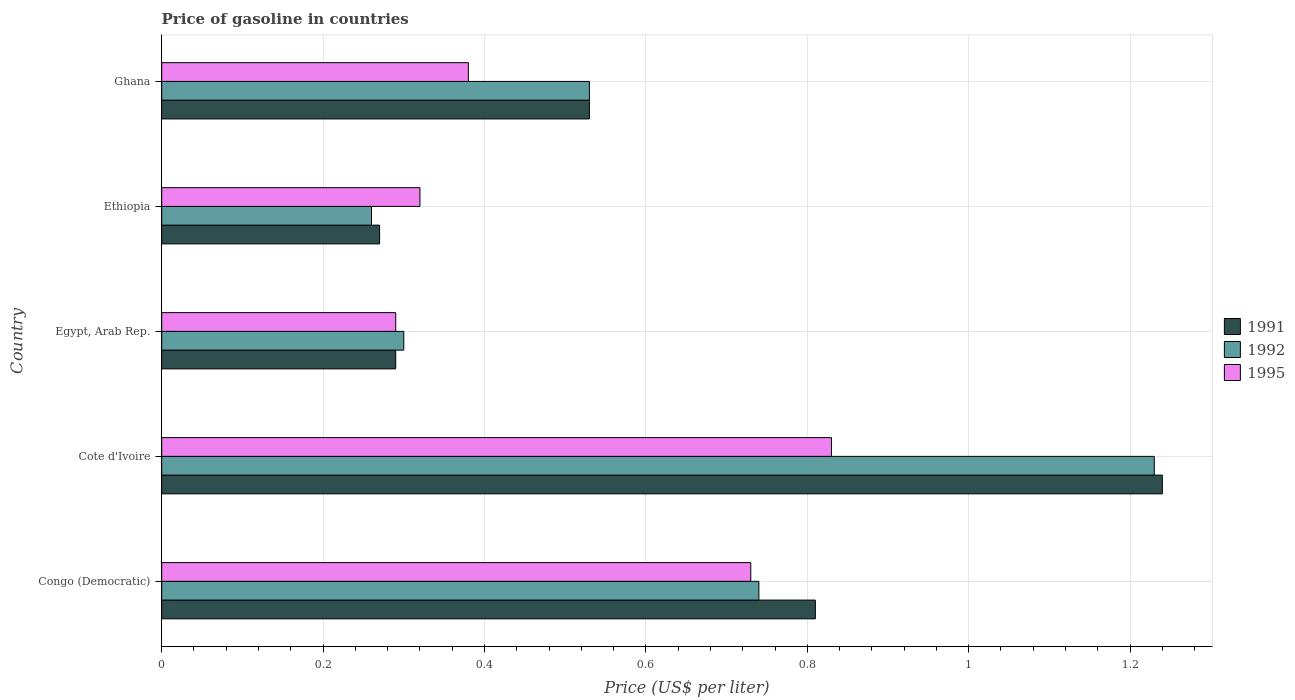How many different coloured bars are there?
Your answer should be compact. 3. How many groups of bars are there?
Your answer should be compact. 5. Are the number of bars per tick equal to the number of legend labels?
Your answer should be very brief. Yes. How many bars are there on the 3rd tick from the top?
Your answer should be very brief. 3. How many bars are there on the 3rd tick from the bottom?
Your response must be concise. 3. What is the label of the 4th group of bars from the top?
Your answer should be compact. Cote d'Ivoire. What is the price of gasoline in 1992 in Cote d'Ivoire?
Give a very brief answer. 1.23. Across all countries, what is the maximum price of gasoline in 1991?
Ensure brevity in your answer.  1.24. Across all countries, what is the minimum price of gasoline in 1992?
Ensure brevity in your answer.  0.26. In which country was the price of gasoline in 1995 maximum?
Your answer should be very brief. Cote d'Ivoire. In which country was the price of gasoline in 1992 minimum?
Offer a terse response. Ethiopia. What is the total price of gasoline in 1992 in the graph?
Your answer should be compact. 3.06. What is the difference between the price of gasoline in 1992 in Egypt, Arab Rep. and that in Ethiopia?
Make the answer very short. 0.04. What is the difference between the price of gasoline in 1995 in Ghana and the price of gasoline in 1992 in Cote d'Ivoire?
Your answer should be compact. -0.85. What is the average price of gasoline in 1992 per country?
Provide a succinct answer. 0.61. What is the difference between the price of gasoline in 1995 and price of gasoline in 1991 in Ghana?
Offer a very short reply. -0.15. In how many countries, is the price of gasoline in 1991 greater than 0.7200000000000001 US$?
Your response must be concise. 2. What is the ratio of the price of gasoline in 1991 in Congo (Democratic) to that in Cote d'Ivoire?
Provide a short and direct response. 0.65. Is the difference between the price of gasoline in 1995 in Congo (Democratic) and Ethiopia greater than the difference between the price of gasoline in 1991 in Congo (Democratic) and Ethiopia?
Give a very brief answer. No. What is the difference between the highest and the second highest price of gasoline in 1995?
Give a very brief answer. 0.1. What is the difference between the highest and the lowest price of gasoline in 1995?
Your answer should be very brief. 0.54. What does the 3rd bar from the top in Ghana represents?
Offer a very short reply. 1991. What does the 2nd bar from the bottom in Congo (Democratic) represents?
Your answer should be very brief. 1992. How many bars are there?
Provide a short and direct response. 15. What is the difference between two consecutive major ticks on the X-axis?
Your response must be concise. 0.2. Are the values on the major ticks of X-axis written in scientific E-notation?
Offer a terse response. No. Does the graph contain any zero values?
Ensure brevity in your answer.  No. How many legend labels are there?
Provide a succinct answer. 3. What is the title of the graph?
Give a very brief answer. Price of gasoline in countries. What is the label or title of the X-axis?
Make the answer very short. Price (US$ per liter). What is the Price (US$ per liter) in 1991 in Congo (Democratic)?
Provide a short and direct response. 0.81. What is the Price (US$ per liter) of 1992 in Congo (Democratic)?
Give a very brief answer. 0.74. What is the Price (US$ per liter) in 1995 in Congo (Democratic)?
Provide a succinct answer. 0.73. What is the Price (US$ per liter) in 1991 in Cote d'Ivoire?
Your response must be concise. 1.24. What is the Price (US$ per liter) of 1992 in Cote d'Ivoire?
Provide a succinct answer. 1.23. What is the Price (US$ per liter) in 1995 in Cote d'Ivoire?
Make the answer very short. 0.83. What is the Price (US$ per liter) in 1991 in Egypt, Arab Rep.?
Give a very brief answer. 0.29. What is the Price (US$ per liter) of 1995 in Egypt, Arab Rep.?
Your answer should be very brief. 0.29. What is the Price (US$ per liter) of 1991 in Ethiopia?
Your answer should be very brief. 0.27. What is the Price (US$ per liter) of 1992 in Ethiopia?
Your answer should be very brief. 0.26. What is the Price (US$ per liter) in 1995 in Ethiopia?
Provide a short and direct response. 0.32. What is the Price (US$ per liter) in 1991 in Ghana?
Offer a very short reply. 0.53. What is the Price (US$ per liter) of 1992 in Ghana?
Keep it short and to the point. 0.53. What is the Price (US$ per liter) of 1995 in Ghana?
Give a very brief answer. 0.38. Across all countries, what is the maximum Price (US$ per liter) in 1991?
Provide a short and direct response. 1.24. Across all countries, what is the maximum Price (US$ per liter) in 1992?
Provide a short and direct response. 1.23. Across all countries, what is the maximum Price (US$ per liter) in 1995?
Give a very brief answer. 0.83. Across all countries, what is the minimum Price (US$ per liter) in 1991?
Your response must be concise. 0.27. Across all countries, what is the minimum Price (US$ per liter) of 1992?
Your answer should be very brief. 0.26. Across all countries, what is the minimum Price (US$ per liter) in 1995?
Offer a terse response. 0.29. What is the total Price (US$ per liter) in 1991 in the graph?
Provide a short and direct response. 3.14. What is the total Price (US$ per liter) of 1992 in the graph?
Your answer should be very brief. 3.06. What is the total Price (US$ per liter) of 1995 in the graph?
Provide a succinct answer. 2.55. What is the difference between the Price (US$ per liter) in 1991 in Congo (Democratic) and that in Cote d'Ivoire?
Your answer should be compact. -0.43. What is the difference between the Price (US$ per liter) of 1992 in Congo (Democratic) and that in Cote d'Ivoire?
Provide a succinct answer. -0.49. What is the difference between the Price (US$ per liter) of 1995 in Congo (Democratic) and that in Cote d'Ivoire?
Provide a succinct answer. -0.1. What is the difference between the Price (US$ per liter) of 1991 in Congo (Democratic) and that in Egypt, Arab Rep.?
Offer a very short reply. 0.52. What is the difference between the Price (US$ per liter) of 1992 in Congo (Democratic) and that in Egypt, Arab Rep.?
Offer a very short reply. 0.44. What is the difference between the Price (US$ per liter) of 1995 in Congo (Democratic) and that in Egypt, Arab Rep.?
Make the answer very short. 0.44. What is the difference between the Price (US$ per liter) of 1991 in Congo (Democratic) and that in Ethiopia?
Offer a terse response. 0.54. What is the difference between the Price (US$ per liter) in 1992 in Congo (Democratic) and that in Ethiopia?
Provide a short and direct response. 0.48. What is the difference between the Price (US$ per liter) in 1995 in Congo (Democratic) and that in Ethiopia?
Give a very brief answer. 0.41. What is the difference between the Price (US$ per liter) of 1991 in Congo (Democratic) and that in Ghana?
Your response must be concise. 0.28. What is the difference between the Price (US$ per liter) of 1992 in Congo (Democratic) and that in Ghana?
Offer a very short reply. 0.21. What is the difference between the Price (US$ per liter) of 1995 in Congo (Democratic) and that in Ghana?
Ensure brevity in your answer.  0.35. What is the difference between the Price (US$ per liter) of 1991 in Cote d'Ivoire and that in Egypt, Arab Rep.?
Provide a short and direct response. 0.95. What is the difference between the Price (US$ per liter) of 1992 in Cote d'Ivoire and that in Egypt, Arab Rep.?
Provide a succinct answer. 0.93. What is the difference between the Price (US$ per liter) of 1995 in Cote d'Ivoire and that in Egypt, Arab Rep.?
Provide a short and direct response. 0.54. What is the difference between the Price (US$ per liter) in 1991 in Cote d'Ivoire and that in Ethiopia?
Make the answer very short. 0.97. What is the difference between the Price (US$ per liter) of 1992 in Cote d'Ivoire and that in Ethiopia?
Provide a short and direct response. 0.97. What is the difference between the Price (US$ per liter) of 1995 in Cote d'Ivoire and that in Ethiopia?
Offer a terse response. 0.51. What is the difference between the Price (US$ per liter) in 1991 in Cote d'Ivoire and that in Ghana?
Provide a succinct answer. 0.71. What is the difference between the Price (US$ per liter) in 1995 in Cote d'Ivoire and that in Ghana?
Give a very brief answer. 0.45. What is the difference between the Price (US$ per liter) of 1991 in Egypt, Arab Rep. and that in Ethiopia?
Your answer should be compact. 0.02. What is the difference between the Price (US$ per liter) in 1995 in Egypt, Arab Rep. and that in Ethiopia?
Your answer should be very brief. -0.03. What is the difference between the Price (US$ per liter) in 1991 in Egypt, Arab Rep. and that in Ghana?
Offer a very short reply. -0.24. What is the difference between the Price (US$ per liter) of 1992 in Egypt, Arab Rep. and that in Ghana?
Your answer should be compact. -0.23. What is the difference between the Price (US$ per liter) in 1995 in Egypt, Arab Rep. and that in Ghana?
Provide a short and direct response. -0.09. What is the difference between the Price (US$ per liter) of 1991 in Ethiopia and that in Ghana?
Keep it short and to the point. -0.26. What is the difference between the Price (US$ per liter) of 1992 in Ethiopia and that in Ghana?
Provide a short and direct response. -0.27. What is the difference between the Price (US$ per liter) in 1995 in Ethiopia and that in Ghana?
Give a very brief answer. -0.06. What is the difference between the Price (US$ per liter) in 1991 in Congo (Democratic) and the Price (US$ per liter) in 1992 in Cote d'Ivoire?
Your answer should be very brief. -0.42. What is the difference between the Price (US$ per liter) of 1991 in Congo (Democratic) and the Price (US$ per liter) of 1995 in Cote d'Ivoire?
Provide a short and direct response. -0.02. What is the difference between the Price (US$ per liter) in 1992 in Congo (Democratic) and the Price (US$ per liter) in 1995 in Cote d'Ivoire?
Give a very brief answer. -0.09. What is the difference between the Price (US$ per liter) in 1991 in Congo (Democratic) and the Price (US$ per liter) in 1992 in Egypt, Arab Rep.?
Offer a terse response. 0.51. What is the difference between the Price (US$ per liter) of 1991 in Congo (Democratic) and the Price (US$ per liter) of 1995 in Egypt, Arab Rep.?
Your answer should be compact. 0.52. What is the difference between the Price (US$ per liter) of 1992 in Congo (Democratic) and the Price (US$ per liter) of 1995 in Egypt, Arab Rep.?
Your answer should be compact. 0.45. What is the difference between the Price (US$ per liter) in 1991 in Congo (Democratic) and the Price (US$ per liter) in 1992 in Ethiopia?
Your answer should be compact. 0.55. What is the difference between the Price (US$ per liter) in 1991 in Congo (Democratic) and the Price (US$ per liter) in 1995 in Ethiopia?
Offer a very short reply. 0.49. What is the difference between the Price (US$ per liter) in 1992 in Congo (Democratic) and the Price (US$ per liter) in 1995 in Ethiopia?
Offer a terse response. 0.42. What is the difference between the Price (US$ per liter) of 1991 in Congo (Democratic) and the Price (US$ per liter) of 1992 in Ghana?
Keep it short and to the point. 0.28. What is the difference between the Price (US$ per liter) in 1991 in Congo (Democratic) and the Price (US$ per liter) in 1995 in Ghana?
Keep it short and to the point. 0.43. What is the difference between the Price (US$ per liter) of 1992 in Congo (Democratic) and the Price (US$ per liter) of 1995 in Ghana?
Provide a short and direct response. 0.36. What is the difference between the Price (US$ per liter) of 1991 in Cote d'Ivoire and the Price (US$ per liter) of 1995 in Egypt, Arab Rep.?
Offer a very short reply. 0.95. What is the difference between the Price (US$ per liter) of 1992 in Cote d'Ivoire and the Price (US$ per liter) of 1995 in Egypt, Arab Rep.?
Offer a very short reply. 0.94. What is the difference between the Price (US$ per liter) in 1992 in Cote d'Ivoire and the Price (US$ per liter) in 1995 in Ethiopia?
Your answer should be compact. 0.91. What is the difference between the Price (US$ per liter) of 1991 in Cote d'Ivoire and the Price (US$ per liter) of 1992 in Ghana?
Your response must be concise. 0.71. What is the difference between the Price (US$ per liter) in 1991 in Cote d'Ivoire and the Price (US$ per liter) in 1995 in Ghana?
Your answer should be compact. 0.86. What is the difference between the Price (US$ per liter) in 1992 in Cote d'Ivoire and the Price (US$ per liter) in 1995 in Ghana?
Ensure brevity in your answer.  0.85. What is the difference between the Price (US$ per liter) in 1991 in Egypt, Arab Rep. and the Price (US$ per liter) in 1992 in Ethiopia?
Offer a terse response. 0.03. What is the difference between the Price (US$ per liter) in 1991 in Egypt, Arab Rep. and the Price (US$ per liter) in 1995 in Ethiopia?
Your answer should be very brief. -0.03. What is the difference between the Price (US$ per liter) in 1992 in Egypt, Arab Rep. and the Price (US$ per liter) in 1995 in Ethiopia?
Keep it short and to the point. -0.02. What is the difference between the Price (US$ per liter) of 1991 in Egypt, Arab Rep. and the Price (US$ per liter) of 1992 in Ghana?
Provide a short and direct response. -0.24. What is the difference between the Price (US$ per liter) in 1991 in Egypt, Arab Rep. and the Price (US$ per liter) in 1995 in Ghana?
Give a very brief answer. -0.09. What is the difference between the Price (US$ per liter) in 1992 in Egypt, Arab Rep. and the Price (US$ per liter) in 1995 in Ghana?
Provide a succinct answer. -0.08. What is the difference between the Price (US$ per liter) of 1991 in Ethiopia and the Price (US$ per liter) of 1992 in Ghana?
Offer a terse response. -0.26. What is the difference between the Price (US$ per liter) of 1991 in Ethiopia and the Price (US$ per liter) of 1995 in Ghana?
Ensure brevity in your answer.  -0.11. What is the difference between the Price (US$ per liter) of 1992 in Ethiopia and the Price (US$ per liter) of 1995 in Ghana?
Provide a succinct answer. -0.12. What is the average Price (US$ per liter) in 1991 per country?
Your response must be concise. 0.63. What is the average Price (US$ per liter) in 1992 per country?
Ensure brevity in your answer.  0.61. What is the average Price (US$ per liter) of 1995 per country?
Make the answer very short. 0.51. What is the difference between the Price (US$ per liter) in 1991 and Price (US$ per liter) in 1992 in Congo (Democratic)?
Provide a succinct answer. 0.07. What is the difference between the Price (US$ per liter) in 1991 and Price (US$ per liter) in 1995 in Congo (Democratic)?
Your response must be concise. 0.08. What is the difference between the Price (US$ per liter) in 1991 and Price (US$ per liter) in 1995 in Cote d'Ivoire?
Offer a very short reply. 0.41. What is the difference between the Price (US$ per liter) of 1992 and Price (US$ per liter) of 1995 in Cote d'Ivoire?
Offer a very short reply. 0.4. What is the difference between the Price (US$ per liter) of 1991 and Price (US$ per liter) of 1992 in Egypt, Arab Rep.?
Give a very brief answer. -0.01. What is the difference between the Price (US$ per liter) of 1991 and Price (US$ per liter) of 1992 in Ethiopia?
Provide a short and direct response. 0.01. What is the difference between the Price (US$ per liter) in 1991 and Price (US$ per liter) in 1995 in Ethiopia?
Offer a terse response. -0.05. What is the difference between the Price (US$ per liter) of 1992 and Price (US$ per liter) of 1995 in Ethiopia?
Keep it short and to the point. -0.06. What is the difference between the Price (US$ per liter) in 1991 and Price (US$ per liter) in 1992 in Ghana?
Provide a short and direct response. 0. What is the difference between the Price (US$ per liter) of 1991 and Price (US$ per liter) of 1995 in Ghana?
Keep it short and to the point. 0.15. What is the ratio of the Price (US$ per liter) of 1991 in Congo (Democratic) to that in Cote d'Ivoire?
Your answer should be compact. 0.65. What is the ratio of the Price (US$ per liter) of 1992 in Congo (Democratic) to that in Cote d'Ivoire?
Make the answer very short. 0.6. What is the ratio of the Price (US$ per liter) in 1995 in Congo (Democratic) to that in Cote d'Ivoire?
Keep it short and to the point. 0.88. What is the ratio of the Price (US$ per liter) of 1991 in Congo (Democratic) to that in Egypt, Arab Rep.?
Keep it short and to the point. 2.79. What is the ratio of the Price (US$ per liter) in 1992 in Congo (Democratic) to that in Egypt, Arab Rep.?
Offer a very short reply. 2.47. What is the ratio of the Price (US$ per liter) in 1995 in Congo (Democratic) to that in Egypt, Arab Rep.?
Offer a very short reply. 2.52. What is the ratio of the Price (US$ per liter) of 1991 in Congo (Democratic) to that in Ethiopia?
Offer a very short reply. 3. What is the ratio of the Price (US$ per liter) of 1992 in Congo (Democratic) to that in Ethiopia?
Make the answer very short. 2.85. What is the ratio of the Price (US$ per liter) in 1995 in Congo (Democratic) to that in Ethiopia?
Provide a short and direct response. 2.28. What is the ratio of the Price (US$ per liter) of 1991 in Congo (Democratic) to that in Ghana?
Offer a very short reply. 1.53. What is the ratio of the Price (US$ per liter) in 1992 in Congo (Democratic) to that in Ghana?
Provide a short and direct response. 1.4. What is the ratio of the Price (US$ per liter) in 1995 in Congo (Democratic) to that in Ghana?
Ensure brevity in your answer.  1.92. What is the ratio of the Price (US$ per liter) in 1991 in Cote d'Ivoire to that in Egypt, Arab Rep.?
Make the answer very short. 4.28. What is the ratio of the Price (US$ per liter) in 1995 in Cote d'Ivoire to that in Egypt, Arab Rep.?
Make the answer very short. 2.86. What is the ratio of the Price (US$ per liter) in 1991 in Cote d'Ivoire to that in Ethiopia?
Make the answer very short. 4.59. What is the ratio of the Price (US$ per liter) in 1992 in Cote d'Ivoire to that in Ethiopia?
Keep it short and to the point. 4.73. What is the ratio of the Price (US$ per liter) in 1995 in Cote d'Ivoire to that in Ethiopia?
Offer a terse response. 2.59. What is the ratio of the Price (US$ per liter) in 1991 in Cote d'Ivoire to that in Ghana?
Your answer should be compact. 2.34. What is the ratio of the Price (US$ per liter) of 1992 in Cote d'Ivoire to that in Ghana?
Provide a succinct answer. 2.32. What is the ratio of the Price (US$ per liter) in 1995 in Cote d'Ivoire to that in Ghana?
Your response must be concise. 2.18. What is the ratio of the Price (US$ per liter) in 1991 in Egypt, Arab Rep. to that in Ethiopia?
Offer a very short reply. 1.07. What is the ratio of the Price (US$ per liter) of 1992 in Egypt, Arab Rep. to that in Ethiopia?
Offer a very short reply. 1.15. What is the ratio of the Price (US$ per liter) in 1995 in Egypt, Arab Rep. to that in Ethiopia?
Your response must be concise. 0.91. What is the ratio of the Price (US$ per liter) of 1991 in Egypt, Arab Rep. to that in Ghana?
Offer a very short reply. 0.55. What is the ratio of the Price (US$ per liter) of 1992 in Egypt, Arab Rep. to that in Ghana?
Offer a terse response. 0.57. What is the ratio of the Price (US$ per liter) in 1995 in Egypt, Arab Rep. to that in Ghana?
Keep it short and to the point. 0.76. What is the ratio of the Price (US$ per liter) in 1991 in Ethiopia to that in Ghana?
Give a very brief answer. 0.51. What is the ratio of the Price (US$ per liter) of 1992 in Ethiopia to that in Ghana?
Offer a very short reply. 0.49. What is the ratio of the Price (US$ per liter) of 1995 in Ethiopia to that in Ghana?
Keep it short and to the point. 0.84. What is the difference between the highest and the second highest Price (US$ per liter) of 1991?
Ensure brevity in your answer.  0.43. What is the difference between the highest and the second highest Price (US$ per liter) of 1992?
Offer a very short reply. 0.49. What is the difference between the highest and the lowest Price (US$ per liter) of 1991?
Your answer should be very brief. 0.97. What is the difference between the highest and the lowest Price (US$ per liter) in 1995?
Give a very brief answer. 0.54. 